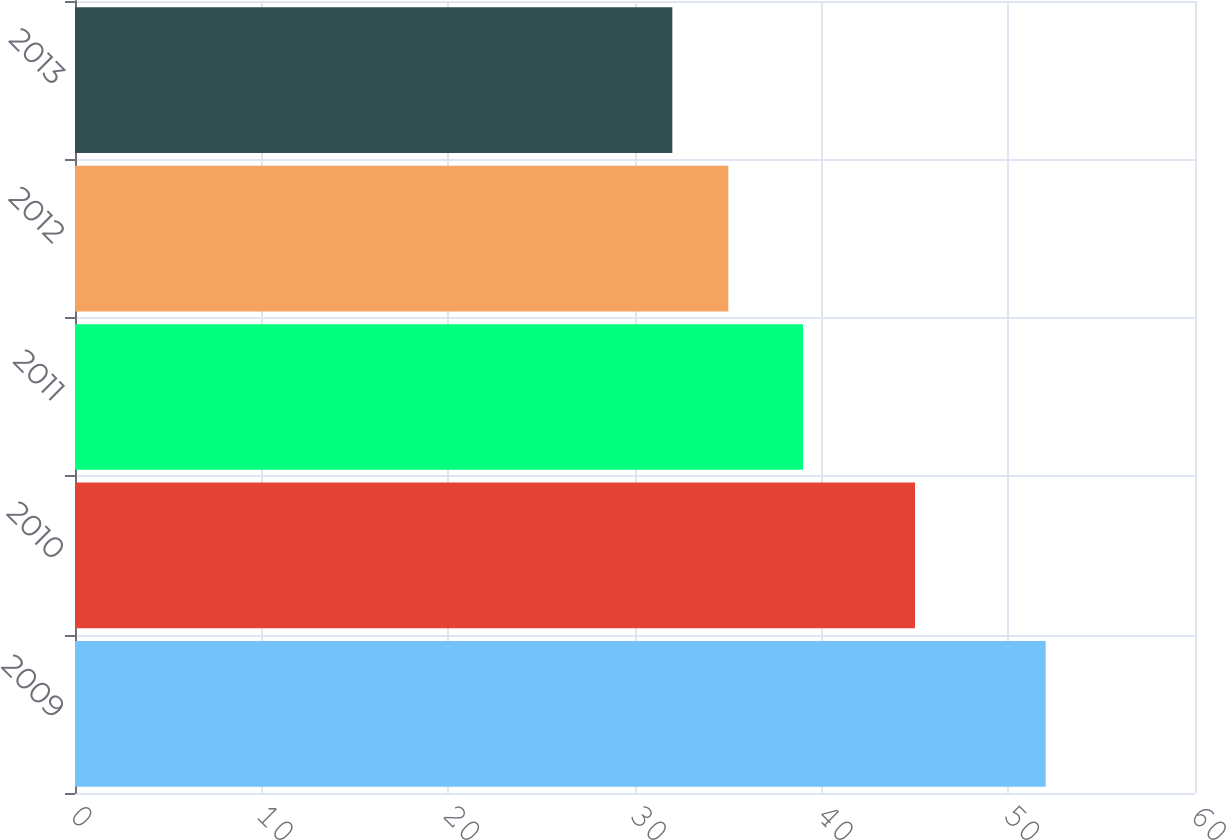Convert chart. <chart><loc_0><loc_0><loc_500><loc_500><bar_chart><fcel>2009<fcel>2010<fcel>2011<fcel>2012<fcel>2013<nl><fcel>52<fcel>45<fcel>39<fcel>35<fcel>32<nl></chart> 